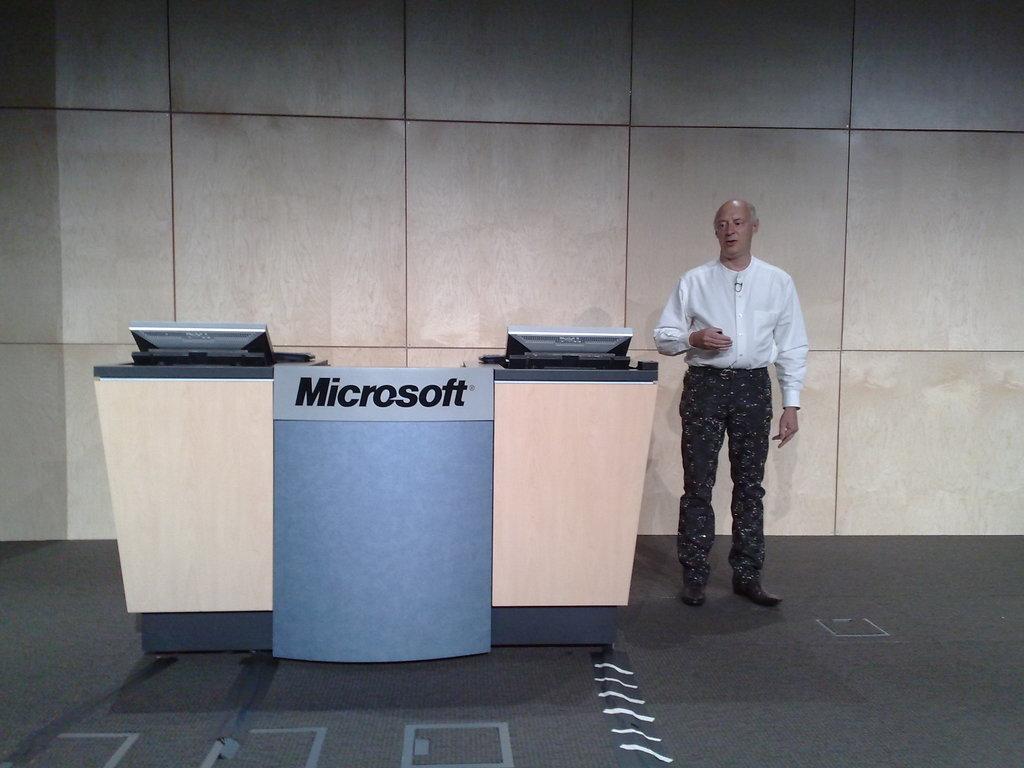What company is advertising on the desk?
Your response must be concise. Microsoft. 